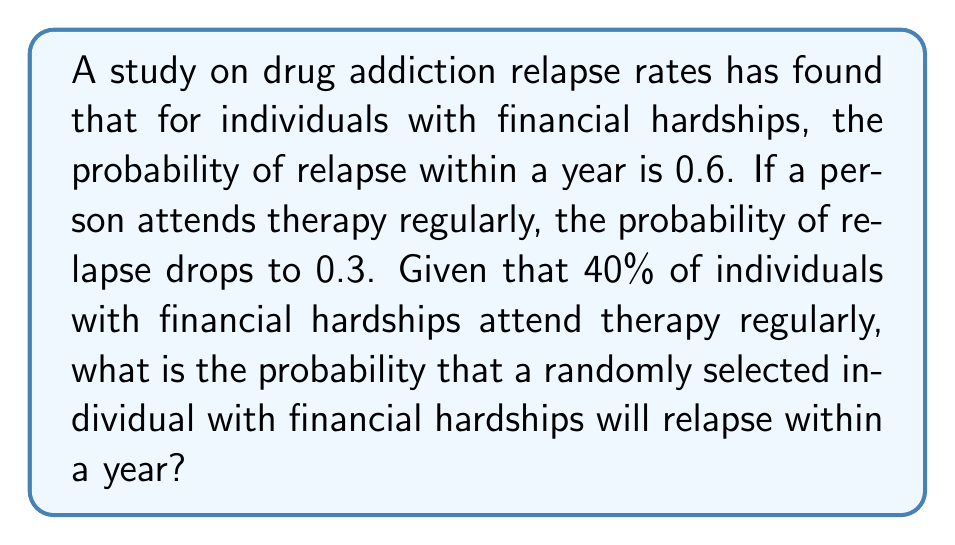Solve this math problem. To solve this problem, we'll use the law of total probability. Let's define our events:

$R$: The event of relapsing within a year
$T$: The event of attending therapy regularly

We're given the following probabilities:

$P(R|T) = 0.3$ (probability of relapse given therapy attendance)
$P(R|\neg T) = 0.6$ (probability of relapse given no therapy attendance)
$P(T) = 0.4$ (probability of attending therapy)

The law of total probability states:

$$P(R) = P(R|T) \cdot P(T) + P(R|\neg T) \cdot P(\neg T)$$

We know $P(T) = 0.4$, so $P(\neg T) = 1 - P(T) = 0.6$

Let's substitute the values:

$$\begin{align*}
P(R) &= 0.3 \cdot 0.4 + 0.6 \cdot 0.6 \\
&= 0.12 + 0.36 \\
&= 0.48
\end{align*}$$

Therefore, the probability that a randomly selected individual with financial hardships will relapse within a year is 0.48 or 48%.
Answer: 0.48 or 48% 